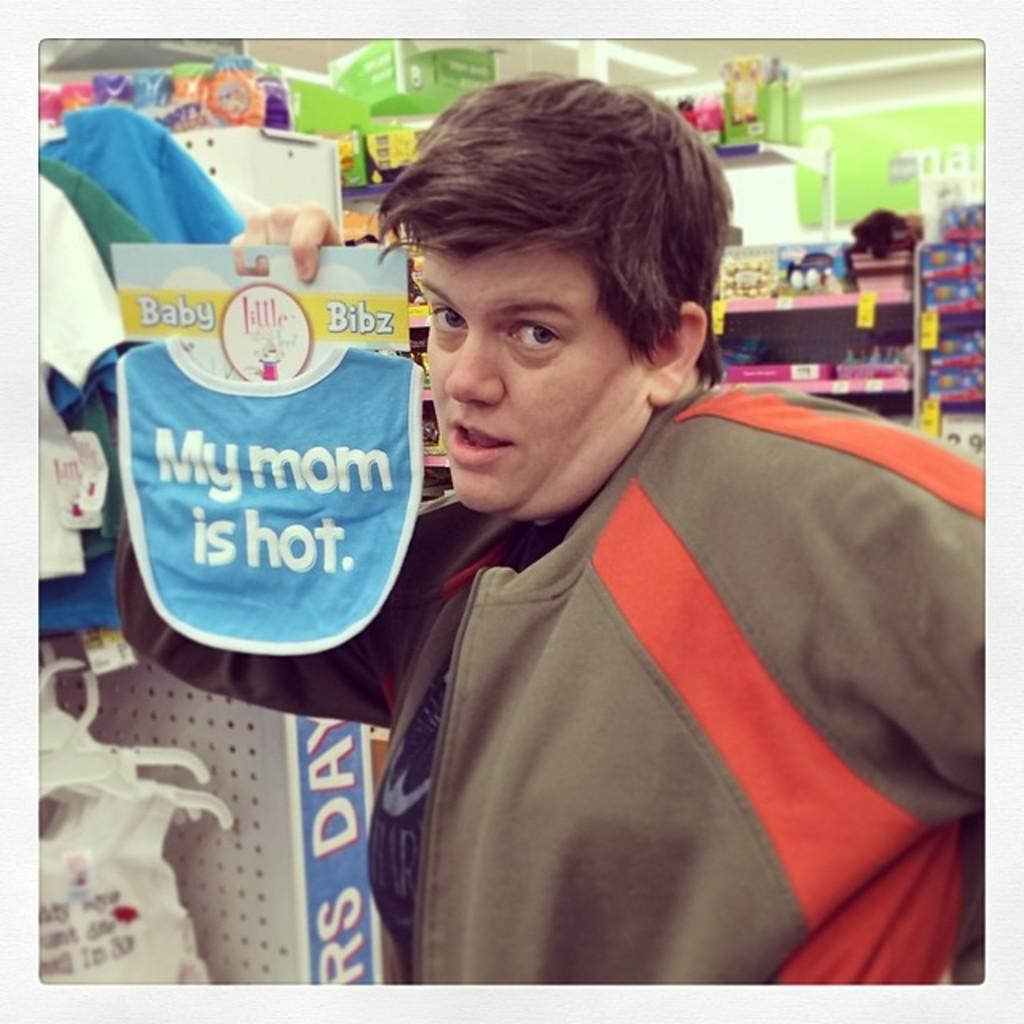<image>
Give a short and clear explanation of the subsequent image. A man in a brown and orange sweater is holding a bib that says my mom is hot on it. 